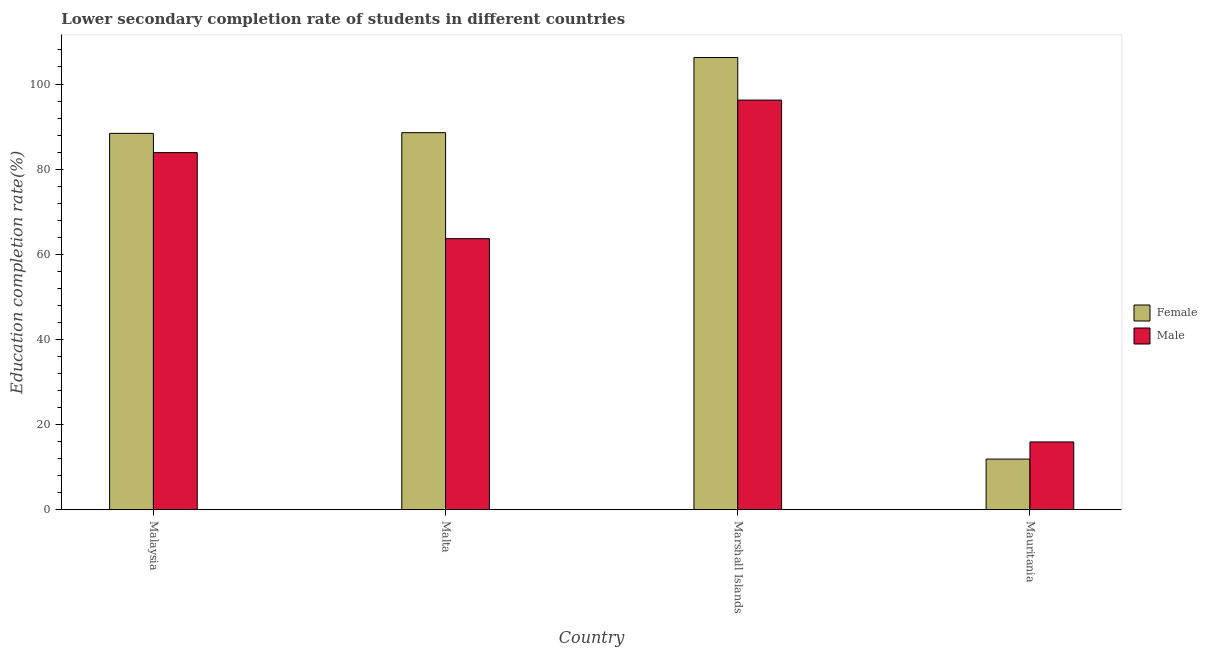How many groups of bars are there?
Keep it short and to the point. 4. Are the number of bars per tick equal to the number of legend labels?
Provide a succinct answer. Yes. How many bars are there on the 1st tick from the right?
Give a very brief answer. 2. What is the label of the 4th group of bars from the left?
Your answer should be compact. Mauritania. In how many cases, is the number of bars for a given country not equal to the number of legend labels?
Offer a terse response. 0. What is the education completion rate of female students in Marshall Islands?
Your answer should be very brief. 106.23. Across all countries, what is the maximum education completion rate of female students?
Your answer should be very brief. 106.23. Across all countries, what is the minimum education completion rate of female students?
Your response must be concise. 11.9. In which country was the education completion rate of female students maximum?
Ensure brevity in your answer.  Marshall Islands. In which country was the education completion rate of female students minimum?
Your answer should be very brief. Mauritania. What is the total education completion rate of female students in the graph?
Make the answer very short. 295.13. What is the difference between the education completion rate of female students in Marshall Islands and that in Mauritania?
Make the answer very short. 94.33. What is the difference between the education completion rate of male students in Marshall Islands and the education completion rate of female students in Mauritania?
Provide a short and direct response. 84.32. What is the average education completion rate of female students per country?
Your answer should be compact. 73.78. What is the difference between the education completion rate of male students and education completion rate of female students in Mauritania?
Your answer should be very brief. 4.03. In how many countries, is the education completion rate of male students greater than 4 %?
Offer a terse response. 4. What is the ratio of the education completion rate of male students in Malaysia to that in Mauritania?
Keep it short and to the point. 5.27. Is the difference between the education completion rate of female students in Marshall Islands and Mauritania greater than the difference between the education completion rate of male students in Marshall Islands and Mauritania?
Offer a very short reply. Yes. What is the difference between the highest and the second highest education completion rate of female students?
Your response must be concise. 17.66. What is the difference between the highest and the lowest education completion rate of male students?
Offer a terse response. 80.3. In how many countries, is the education completion rate of female students greater than the average education completion rate of female students taken over all countries?
Make the answer very short. 3. What does the 1st bar from the left in Mauritania represents?
Your response must be concise. Female. How many bars are there?
Provide a succinct answer. 8. How many countries are there in the graph?
Give a very brief answer. 4. What is the difference between two consecutive major ticks on the Y-axis?
Ensure brevity in your answer.  20. Are the values on the major ticks of Y-axis written in scientific E-notation?
Keep it short and to the point. No. Does the graph contain any zero values?
Make the answer very short. No. Where does the legend appear in the graph?
Keep it short and to the point. Center right. How many legend labels are there?
Your answer should be compact. 2. What is the title of the graph?
Your response must be concise. Lower secondary completion rate of students in different countries. Does "Under-5(female)" appear as one of the legend labels in the graph?
Provide a succinct answer. No. What is the label or title of the Y-axis?
Make the answer very short. Education completion rate(%). What is the Education completion rate(%) in Female in Malaysia?
Offer a terse response. 88.42. What is the Education completion rate(%) in Male in Malaysia?
Offer a very short reply. 83.89. What is the Education completion rate(%) of Female in Malta?
Your answer should be compact. 88.58. What is the Education completion rate(%) of Male in Malta?
Offer a terse response. 63.68. What is the Education completion rate(%) in Female in Marshall Islands?
Keep it short and to the point. 106.23. What is the Education completion rate(%) of Male in Marshall Islands?
Make the answer very short. 96.23. What is the Education completion rate(%) of Female in Mauritania?
Give a very brief answer. 11.9. What is the Education completion rate(%) in Male in Mauritania?
Provide a short and direct response. 15.93. Across all countries, what is the maximum Education completion rate(%) in Female?
Your answer should be compact. 106.23. Across all countries, what is the maximum Education completion rate(%) in Male?
Make the answer very short. 96.23. Across all countries, what is the minimum Education completion rate(%) of Female?
Offer a very short reply. 11.9. Across all countries, what is the minimum Education completion rate(%) in Male?
Ensure brevity in your answer.  15.93. What is the total Education completion rate(%) of Female in the graph?
Keep it short and to the point. 295.13. What is the total Education completion rate(%) in Male in the graph?
Ensure brevity in your answer.  259.73. What is the difference between the Education completion rate(%) of Female in Malaysia and that in Malta?
Your response must be concise. -0.16. What is the difference between the Education completion rate(%) in Male in Malaysia and that in Malta?
Your answer should be very brief. 20.21. What is the difference between the Education completion rate(%) of Female in Malaysia and that in Marshall Islands?
Ensure brevity in your answer.  -17.82. What is the difference between the Education completion rate(%) of Male in Malaysia and that in Marshall Islands?
Offer a terse response. -12.34. What is the difference between the Education completion rate(%) of Female in Malaysia and that in Mauritania?
Your response must be concise. 76.51. What is the difference between the Education completion rate(%) of Male in Malaysia and that in Mauritania?
Keep it short and to the point. 67.96. What is the difference between the Education completion rate(%) of Female in Malta and that in Marshall Islands?
Offer a terse response. -17.66. What is the difference between the Education completion rate(%) in Male in Malta and that in Marshall Islands?
Offer a terse response. -32.55. What is the difference between the Education completion rate(%) in Female in Malta and that in Mauritania?
Your response must be concise. 76.67. What is the difference between the Education completion rate(%) in Male in Malta and that in Mauritania?
Offer a terse response. 47.75. What is the difference between the Education completion rate(%) in Female in Marshall Islands and that in Mauritania?
Ensure brevity in your answer.  94.33. What is the difference between the Education completion rate(%) in Male in Marshall Islands and that in Mauritania?
Keep it short and to the point. 80.3. What is the difference between the Education completion rate(%) in Female in Malaysia and the Education completion rate(%) in Male in Malta?
Provide a succinct answer. 24.74. What is the difference between the Education completion rate(%) in Female in Malaysia and the Education completion rate(%) in Male in Marshall Islands?
Your answer should be compact. -7.81. What is the difference between the Education completion rate(%) of Female in Malaysia and the Education completion rate(%) of Male in Mauritania?
Your response must be concise. 72.48. What is the difference between the Education completion rate(%) in Female in Malta and the Education completion rate(%) in Male in Marshall Islands?
Ensure brevity in your answer.  -7.65. What is the difference between the Education completion rate(%) in Female in Malta and the Education completion rate(%) in Male in Mauritania?
Your answer should be very brief. 72.64. What is the difference between the Education completion rate(%) in Female in Marshall Islands and the Education completion rate(%) in Male in Mauritania?
Your response must be concise. 90.3. What is the average Education completion rate(%) of Female per country?
Provide a succinct answer. 73.78. What is the average Education completion rate(%) of Male per country?
Provide a succinct answer. 64.93. What is the difference between the Education completion rate(%) of Female and Education completion rate(%) of Male in Malaysia?
Provide a succinct answer. 4.52. What is the difference between the Education completion rate(%) of Female and Education completion rate(%) of Male in Malta?
Keep it short and to the point. 24.9. What is the difference between the Education completion rate(%) in Female and Education completion rate(%) in Male in Marshall Islands?
Your answer should be very brief. 10.01. What is the difference between the Education completion rate(%) in Female and Education completion rate(%) in Male in Mauritania?
Make the answer very short. -4.03. What is the ratio of the Education completion rate(%) of Male in Malaysia to that in Malta?
Offer a very short reply. 1.32. What is the ratio of the Education completion rate(%) of Female in Malaysia to that in Marshall Islands?
Your answer should be very brief. 0.83. What is the ratio of the Education completion rate(%) of Male in Malaysia to that in Marshall Islands?
Your answer should be very brief. 0.87. What is the ratio of the Education completion rate(%) of Female in Malaysia to that in Mauritania?
Provide a short and direct response. 7.43. What is the ratio of the Education completion rate(%) of Male in Malaysia to that in Mauritania?
Your response must be concise. 5.27. What is the ratio of the Education completion rate(%) of Female in Malta to that in Marshall Islands?
Your answer should be very brief. 0.83. What is the ratio of the Education completion rate(%) in Male in Malta to that in Marshall Islands?
Your answer should be compact. 0.66. What is the ratio of the Education completion rate(%) of Female in Malta to that in Mauritania?
Offer a terse response. 7.44. What is the ratio of the Education completion rate(%) of Male in Malta to that in Mauritania?
Make the answer very short. 4. What is the ratio of the Education completion rate(%) of Female in Marshall Islands to that in Mauritania?
Ensure brevity in your answer.  8.92. What is the ratio of the Education completion rate(%) of Male in Marshall Islands to that in Mauritania?
Ensure brevity in your answer.  6.04. What is the difference between the highest and the second highest Education completion rate(%) of Female?
Ensure brevity in your answer.  17.66. What is the difference between the highest and the second highest Education completion rate(%) in Male?
Provide a short and direct response. 12.34. What is the difference between the highest and the lowest Education completion rate(%) in Female?
Provide a succinct answer. 94.33. What is the difference between the highest and the lowest Education completion rate(%) in Male?
Offer a terse response. 80.3. 